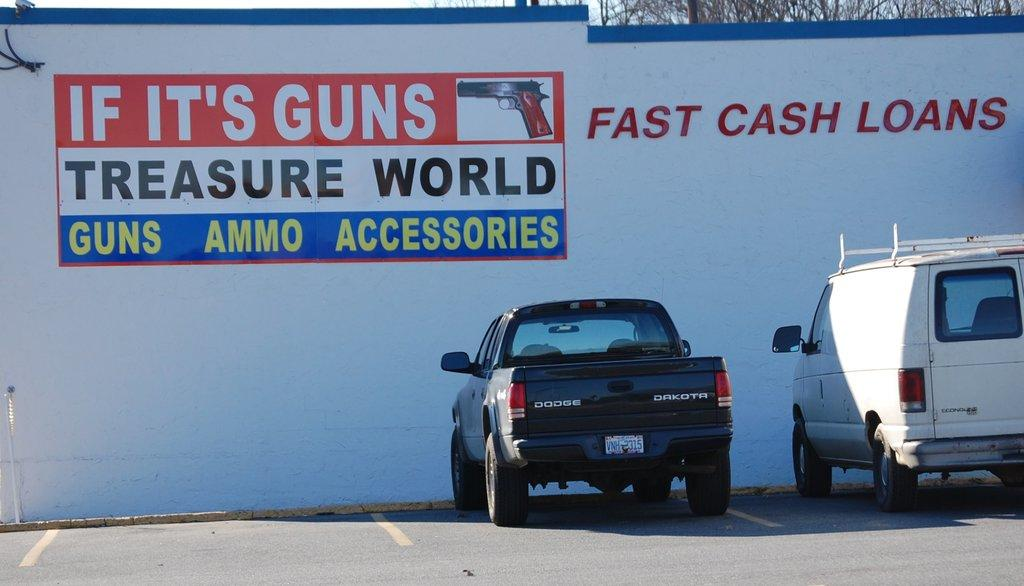<image>
Write a terse but informative summary of the picture. A truck and a van are parked next to a building that says Fast Cash Loans. 